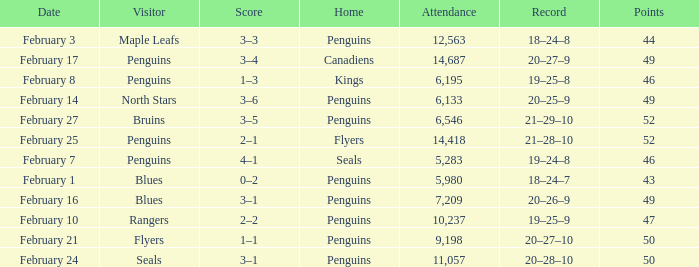Record of 21–29–10 had what total number of points? 1.0. 